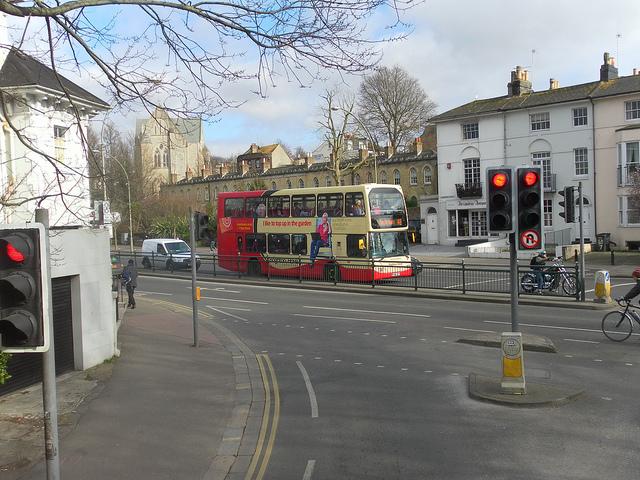What does the lights indicate?
Answer briefly. Stop. What color is the light?
Answer briefly. Red. How many busses in the picture?
Concise answer only. 1. What color is the bus?
Give a very brief answer. Red and white. How many buses are on the street?
Concise answer only. 1. How many red lights are there?
Short answer required. 3. 